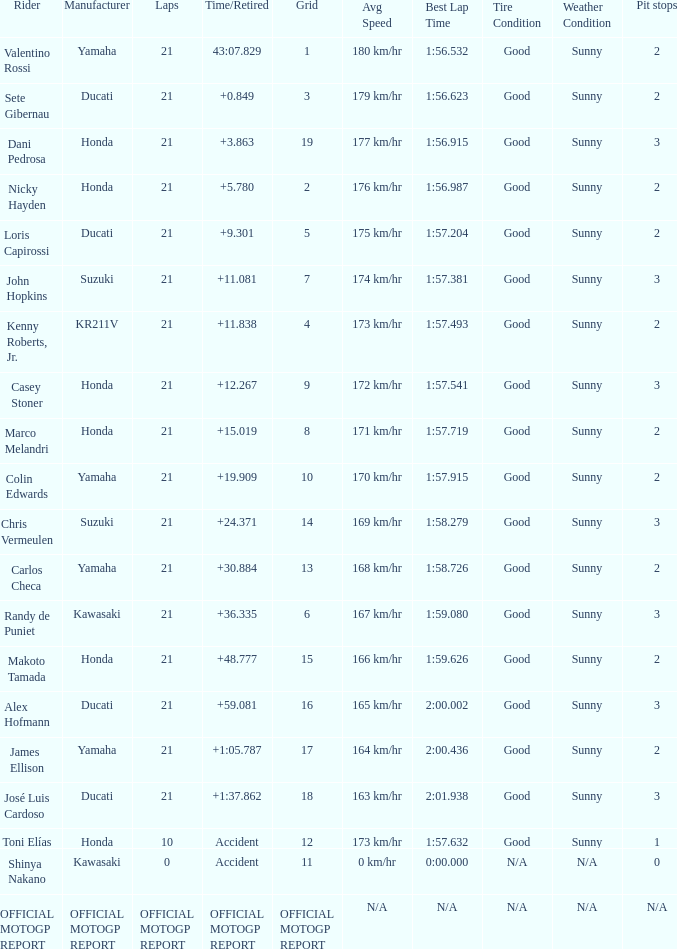What was the amount of laps for the vehicle manufactured by honda with a grid of 9? 21.0. 